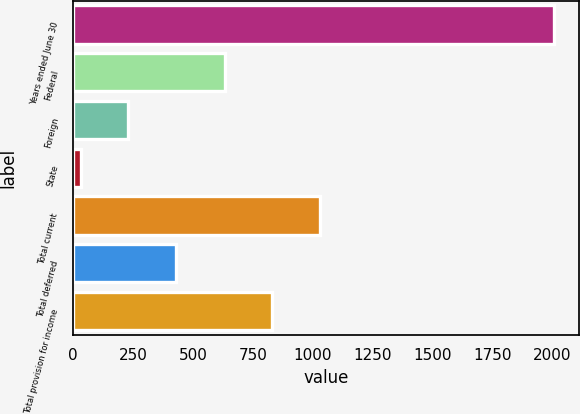Convert chart to OTSL. <chart><loc_0><loc_0><loc_500><loc_500><bar_chart><fcel>Years ended June 30<fcel>Federal<fcel>Foreign<fcel>State<fcel>Total current<fcel>Total deferred<fcel>Total provision for income<nl><fcel>2008<fcel>632.3<fcel>229.15<fcel>31.5<fcel>1027.6<fcel>426.8<fcel>829.95<nl></chart> 